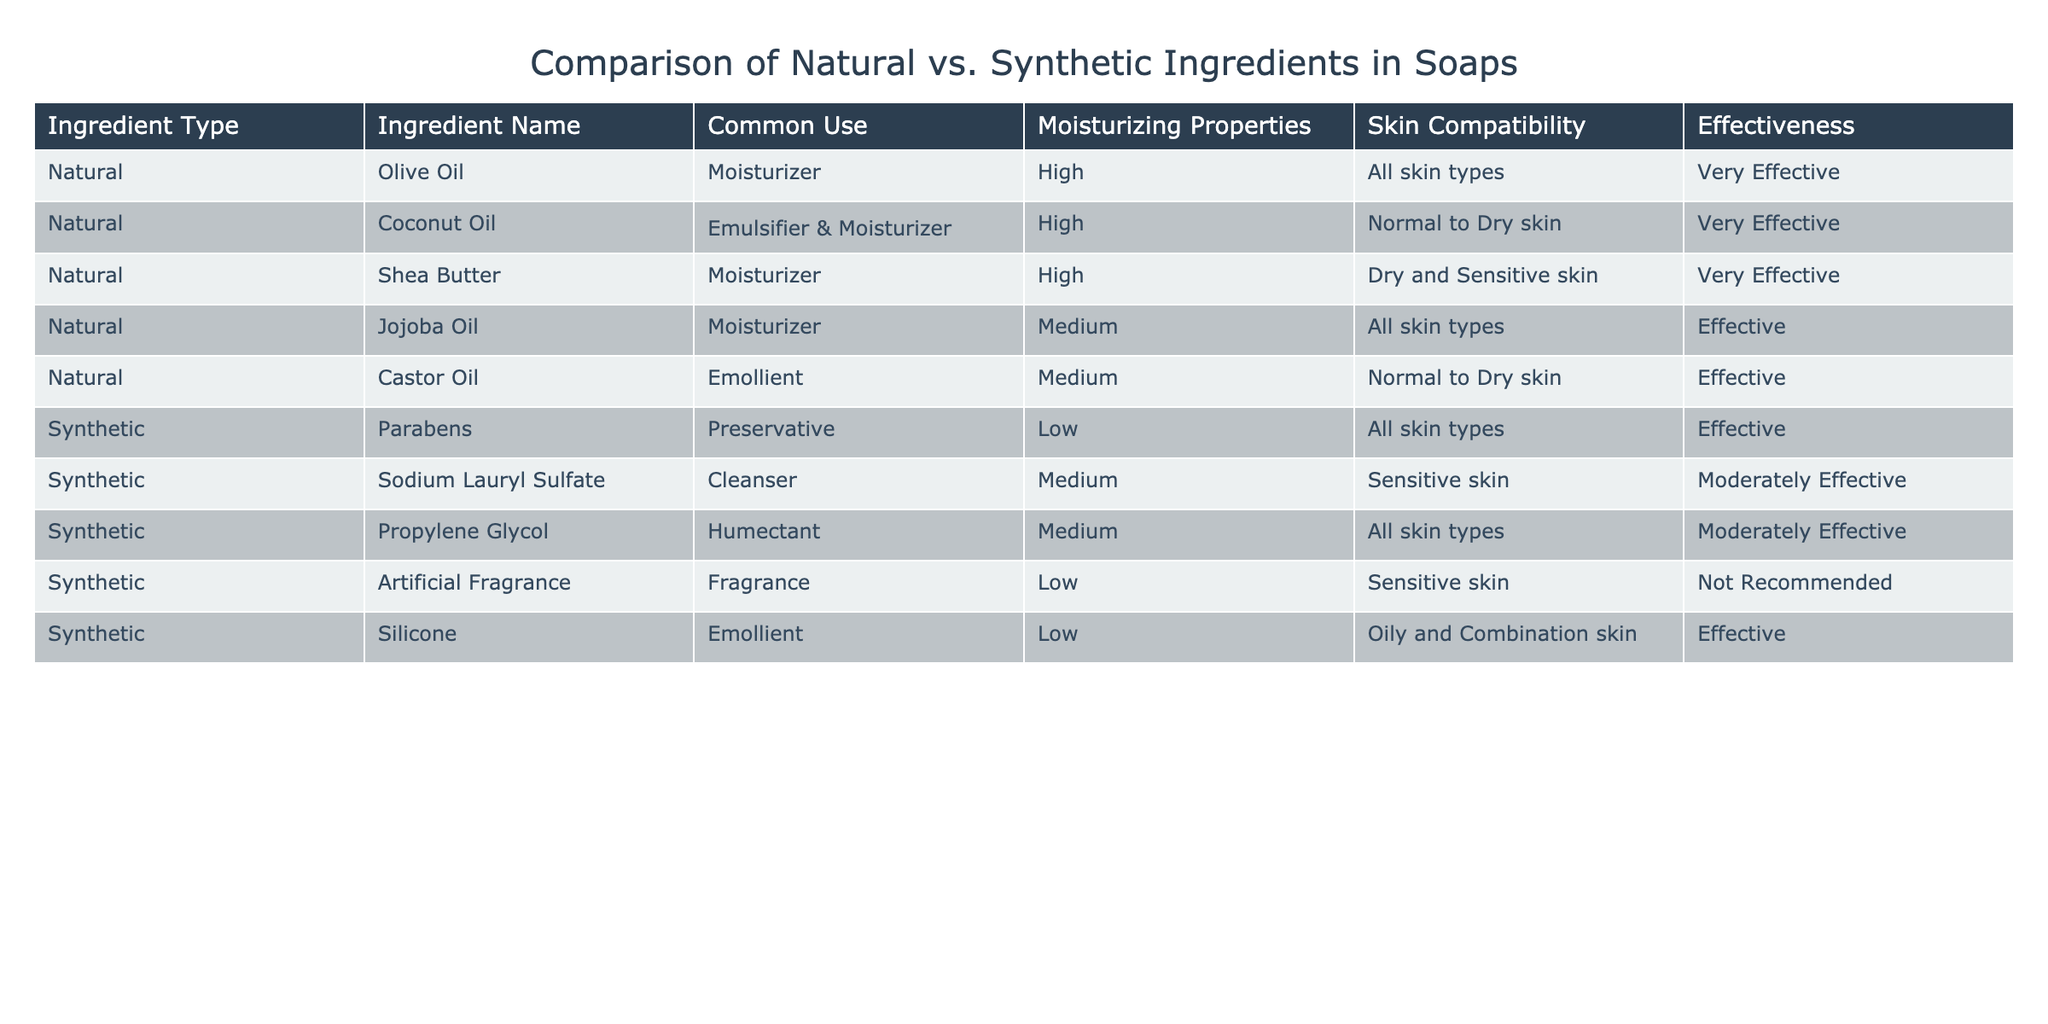What is the skin compatibility of Olive Oil? The table shows that Olive Oil is compatible with all skin types, as indicated in the Skin Compatibility column corresponding to Olive Oil.
Answer: All skin types Which ingredient is considered the most effective moisturizer? According to the Effectiveness column in the table, both Olive Oil, Coconut Oil, and Shea Butter are labeled as "Very Effective" moisturizers. Thus, they share the highest level of effectiveness in this category.
Answer: Olive Oil, Coconut Oil, Shea Butter Is Propylene Glycol considered a synthetic or natural ingredient? By referring to the Ingredient Type column, it can be seen that Propylene Glycol is categorized as a synthetic ingredient.
Answer: Synthetic What is the average moisturizing property score for natural ingredients? The moisturizing properties for all natural ingredients listed (Olive Oil, Coconut Oil, Shea Butter, Jojoba Oil, Castor Oil) are either High or Medium. Assigning High a value of 2 and Medium a value of 1, we have 4 Highs and 1 Medium, which gives an average of (4*2 + 1*1) / 5 = 9 / 5 = 1.8. However, in a qualitative view, most natural ingredients are deemed highly moisturizing.
Answer: 1.8 (Qualitative view: Mostly High) Which type of ingredient has more effectiveness ratings categorized as "Not Recommended"? The table shows that among synthetic ingredients, only Artificial Fragrance is labeled as "Not Recommended," while no natural ingredients have this label. Thus, synthetic ingredients have more "Not Recommended" ratings.
Answer: Synthetic Are all synthetic ingredients effective for sensitive skin? Upon reviewing the table, it is evident that Sodium Lauryl Sulfate and Artificial Fragrance are listed under sensitive skin. While Sodium Lauryl Sulfate has a "Moderately Effective" rating, Artificial Fragrance is explicitly "Not Recommended." Hence, not all synthetic ingredients are effective for sensitive skin.
Answer: No What percentage of natural ingredients have high moisturizing properties? There are 5 natural ingredients in total: Olive Oil, Coconut Oil, Shea Butter, Jojoba Oil, and Castor Oil; 4 of these (Olive Oil, Coconut Oil, Shea Butter) have "High" moisturizing properties. This gives a percentage of (4/5) * 100 = 80%.
Answer: 80% Which ingredient has the lowest moisturizing property? The moisturizing properties rated for all ingredients indicate that Parabens and Artificial Fragrance have "Low" moisturizing properties, but as Parabens is listed as a preservative and not used for moisturizing, while Artificial Fragrance is mostly for scent, we conclude the significant lowest moisturizing ingredient is Artificial Fragrance.
Answer: Artificial Fragrance 